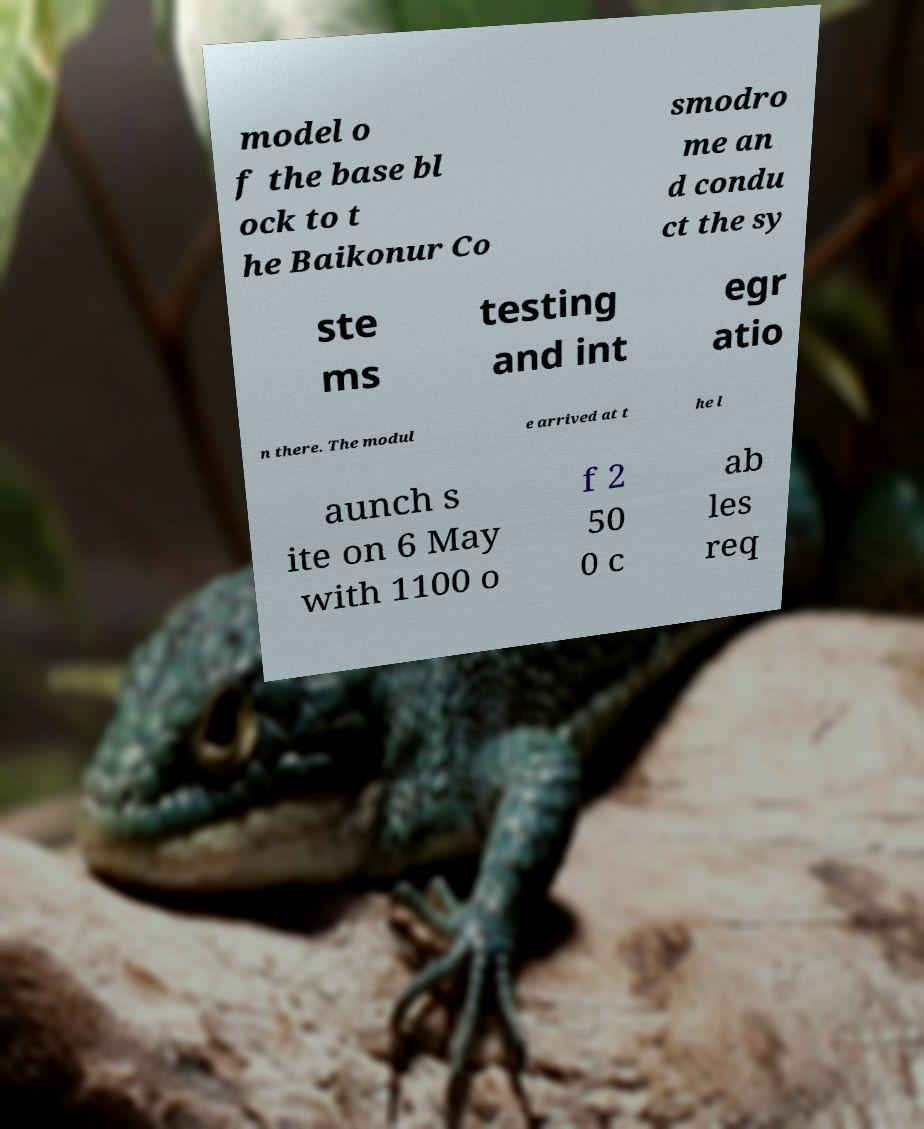Can you accurately transcribe the text from the provided image for me? model o f the base bl ock to t he Baikonur Co smodro me an d condu ct the sy ste ms testing and int egr atio n there. The modul e arrived at t he l aunch s ite on 6 May with 1100 o f 2 50 0 c ab les req 